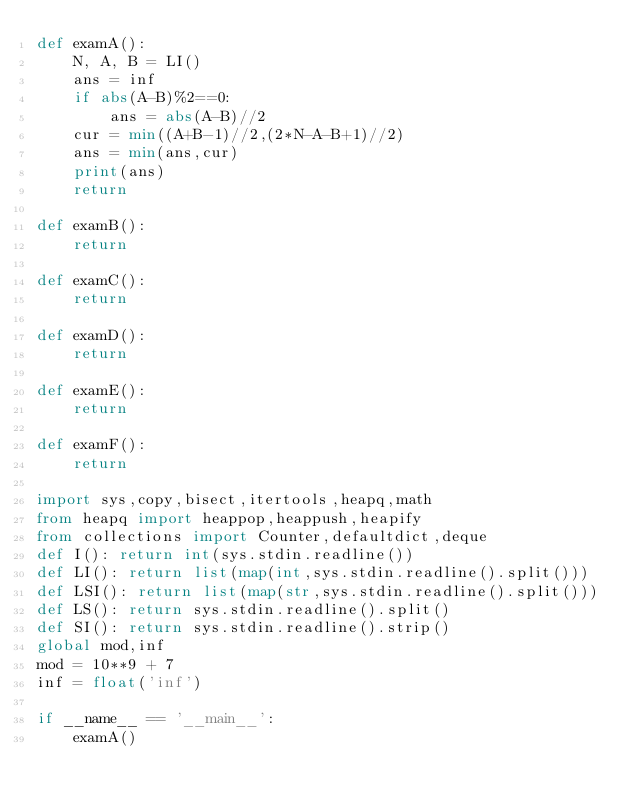<code> <loc_0><loc_0><loc_500><loc_500><_Python_>def examA():
    N, A, B = LI()
    ans = inf
    if abs(A-B)%2==0:
        ans = abs(A-B)//2
    cur = min((A+B-1)//2,(2*N-A-B+1)//2)
    ans = min(ans,cur)
    print(ans)
    return

def examB():
    return

def examC():
    return

def examD():
    return

def examE():
    return

def examF():
    return

import sys,copy,bisect,itertools,heapq,math
from heapq import heappop,heappush,heapify
from collections import Counter,defaultdict,deque
def I(): return int(sys.stdin.readline())
def LI(): return list(map(int,sys.stdin.readline().split()))
def LSI(): return list(map(str,sys.stdin.readline().split()))
def LS(): return sys.stdin.readline().split()
def SI(): return sys.stdin.readline().strip()
global mod,inf
mod = 10**9 + 7
inf = float('inf')

if __name__ == '__main__':
    examA()
</code> 